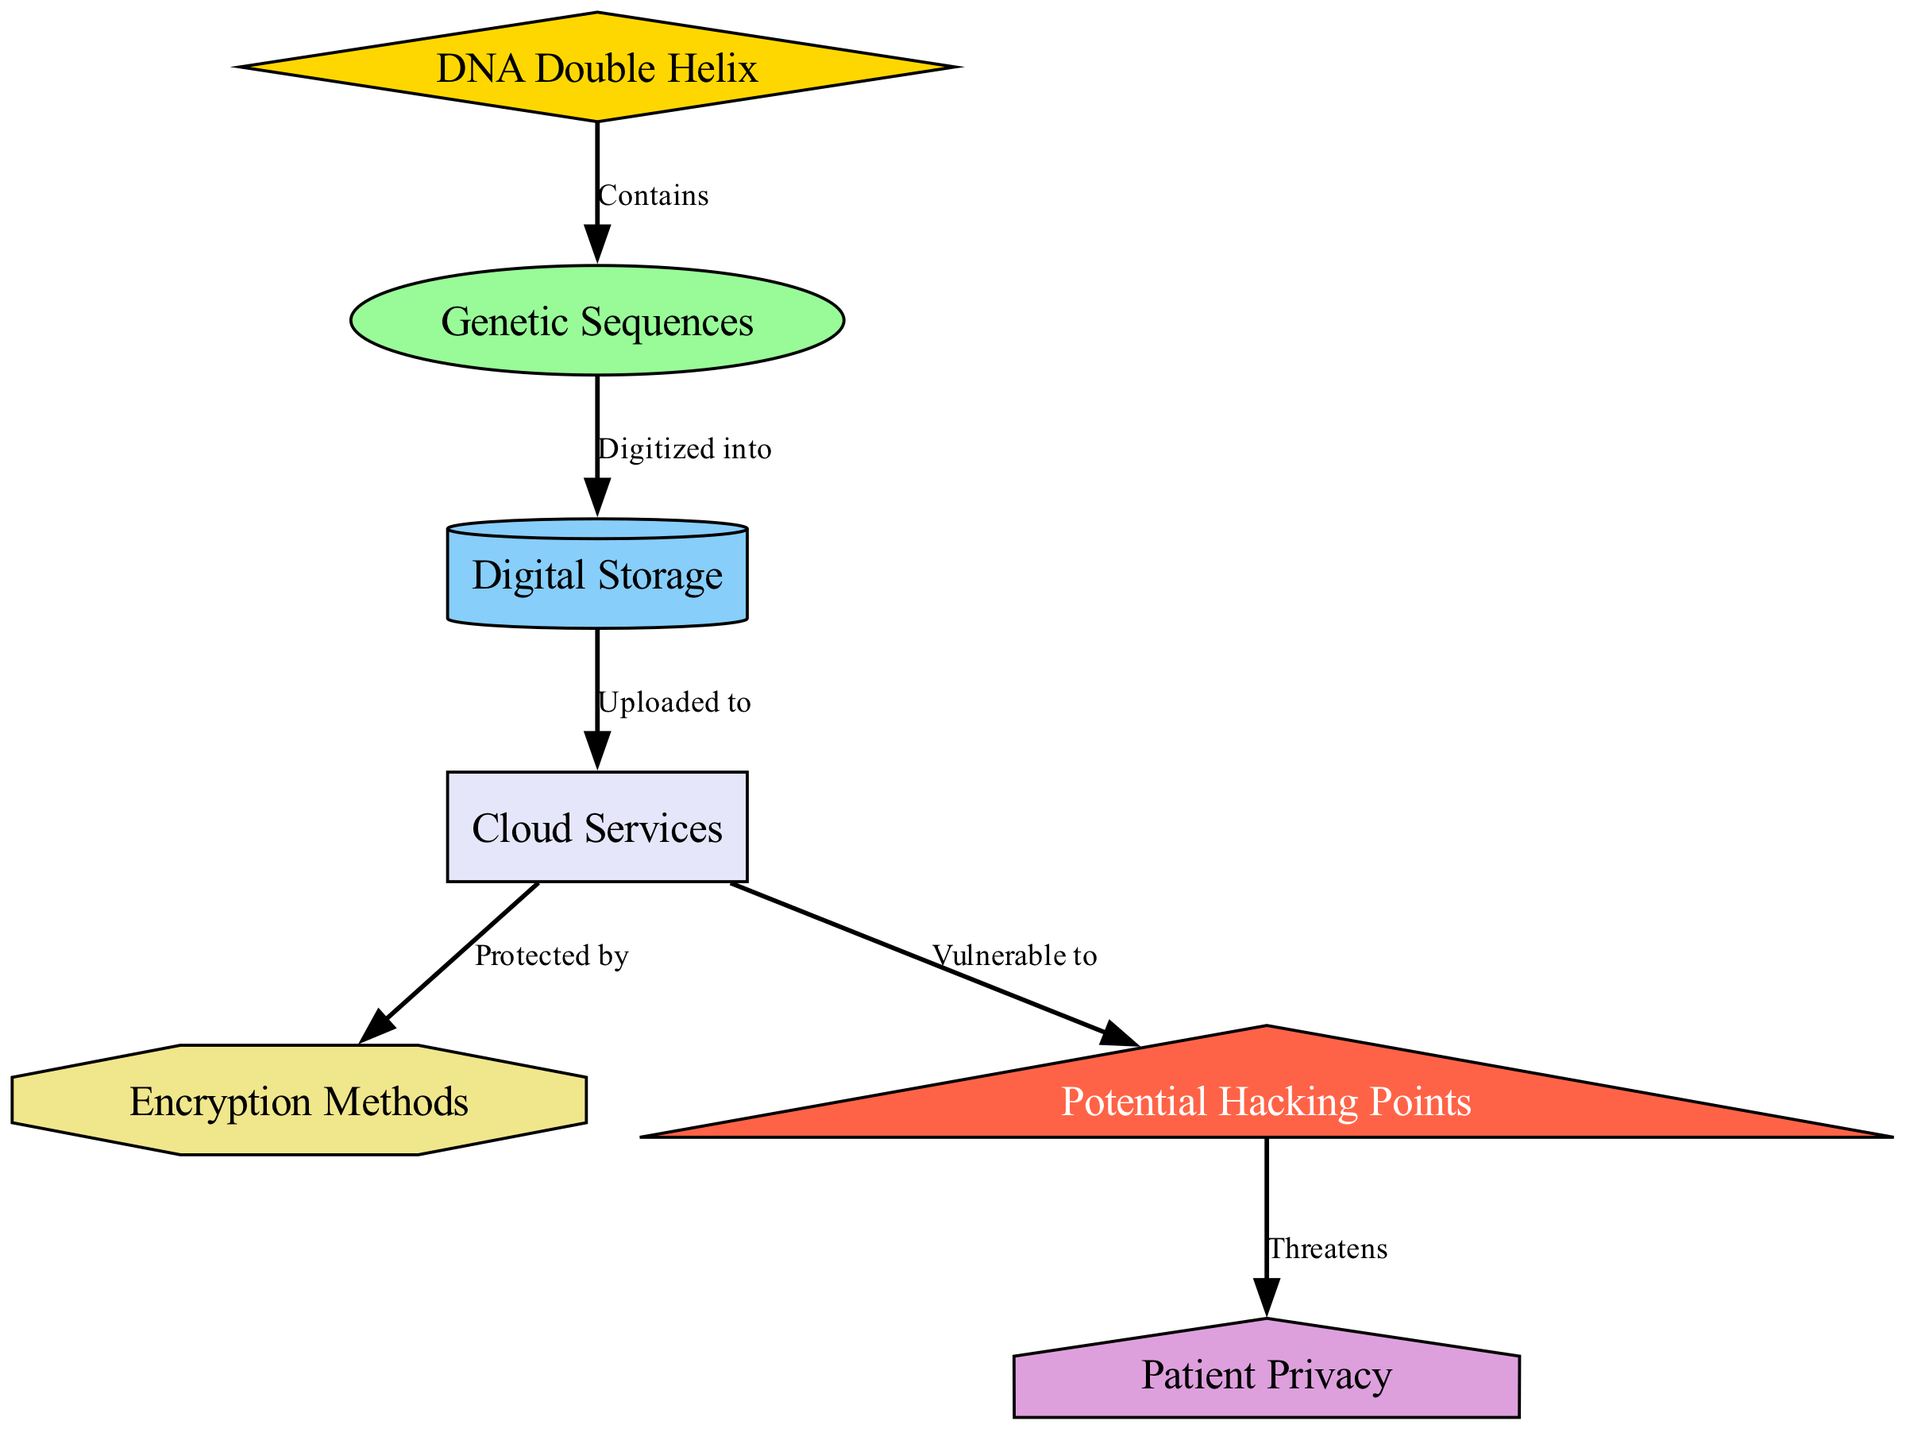What is the first node in the diagram? The diagram presents the DNA double helix as the starting concept, visually situated at the top of the diagram. Hence, it represents the foundational basis of the entire structure that follows.
Answer: DNA Double Helix How many nodes are in the diagram? Counting the nodes listed in the data section, there are a total of 7 nodes that represent various components in the diagram.
Answer: 7 What does the DNA double helix contain? The arrow labeled "Contains" directly connects the DNA double helix node to the genetic sequences node, indicating that the DNA encompasses these genetic sequences.
Answer: Genetic Sequences What does genetic data get digitized into? According to the labeled edge "Digitized into", the genetic sequences node leads to the digital storage node, suggesting that genetic data is transformed into a digital format for storage.
Answer: Digital Storage Which storage method is protected by encryption? The diagram indicates that the cloud services node, connected by an arrow labeled "Protected by", is secured through encryption methods, outlining the layer of security involved.
Answer: Encryption Methods What is a potential threat to patient privacy? The diagram shows that the hacking node, represented as a possible vulnerability in the flow from cloud services, is labeled as a direct threat to patient privacy, indicating the consequences of such security breaches.
Answer: Threatens What is the relationship between digital storage and cloud services? The directed edge "Uploaded to" connects the digital storage node to the cloud services node, illustrating that the data stored digitally transitions to being stored in the cloud environment.
Answer: Uploaded to Which node is vulnerable to hacking? The edge labeled "Vulnerable to" indicates that the cloud services node has a direct connection leading to the hacking node, signifying that the data stored in the cloud is susceptible to intrusion attempts.
Answer: Cloud Services 